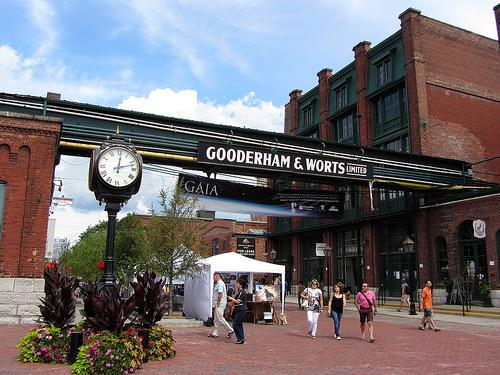Question: what color is the sky?
Choices:
A. Gray.
B. Blue.
C. White.
D. Orange.
Answer with the letter. Answer: B Question: what time is it?
Choices:
A. 3:00.
B. 4:20.
C. 2:00.
D. 7:10.
Answer with the letter. Answer: C Question: what color is the tent?
Choices:
A. Blue.
B. Green.
C. White.
D. Yellow.
Answer with the letter. Answer: C 